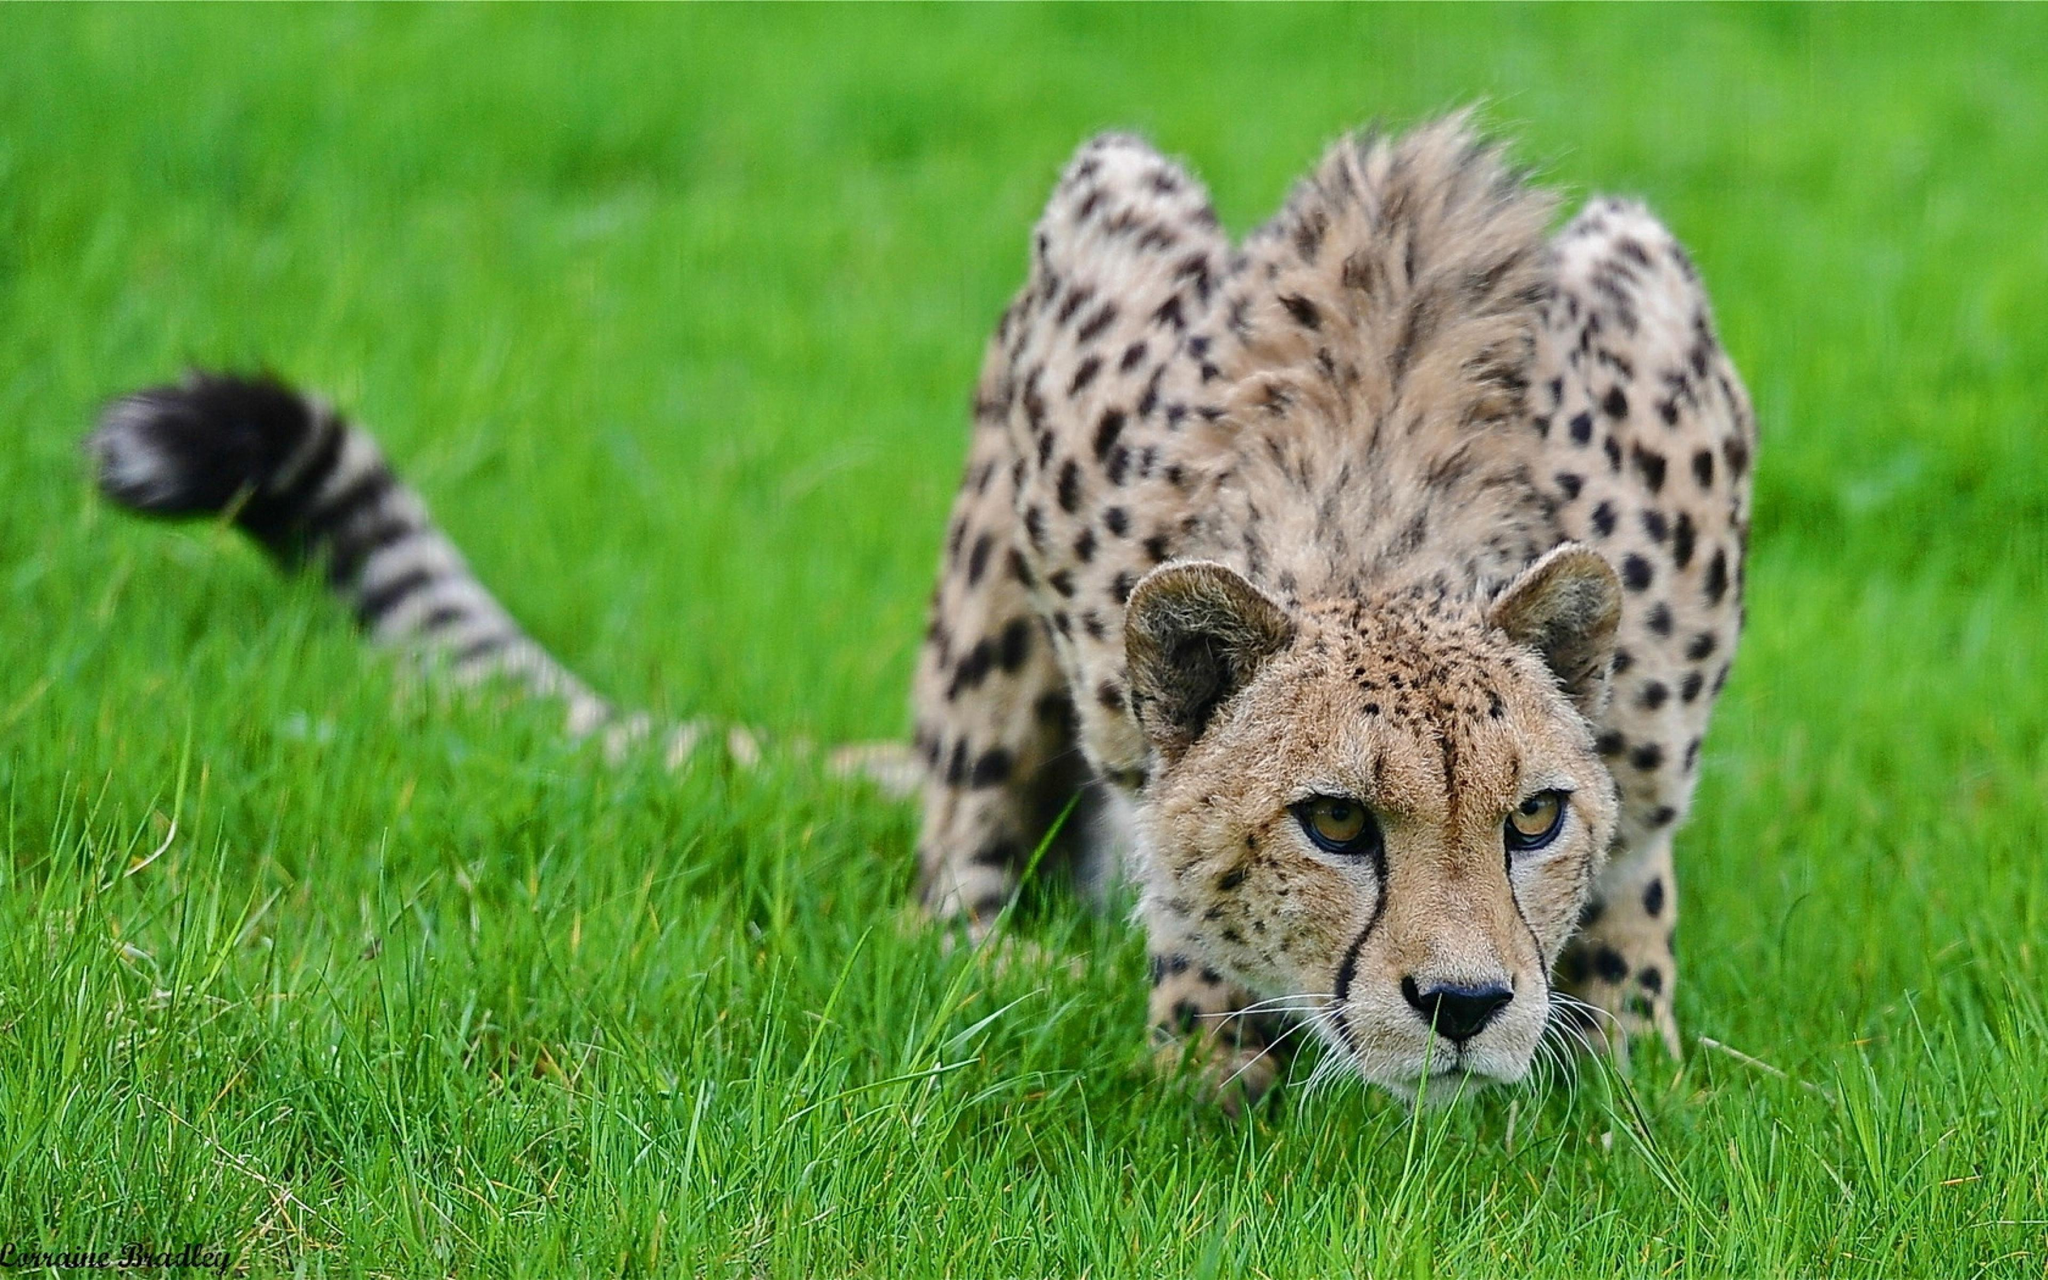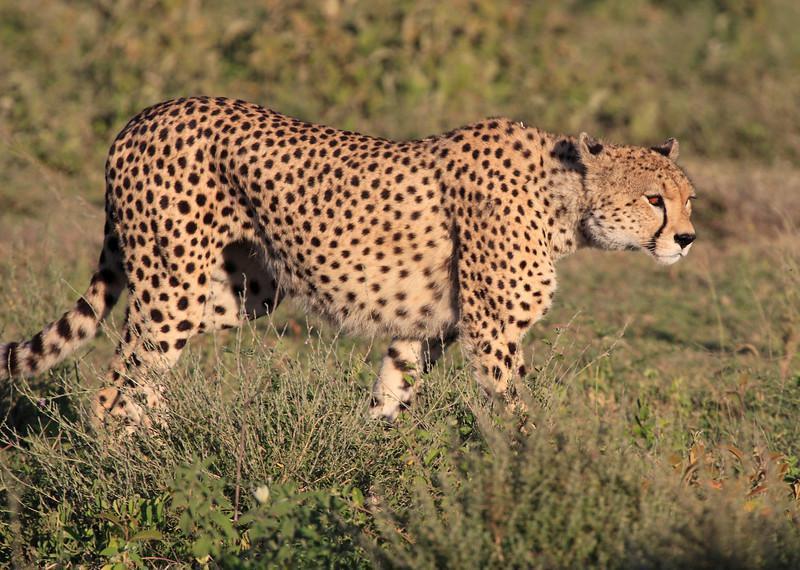The first image is the image on the left, the second image is the image on the right. Given the left and right images, does the statement "Each image contains a single cheetah, with one image showing a rightward facing cheetah, and the other showing a forward-looking cheetah." hold true? Answer yes or no. Yes. The first image is the image on the left, the second image is the image on the right. Assess this claim about the two images: "There are at least four leopards.". Correct or not? Answer yes or no. No. 